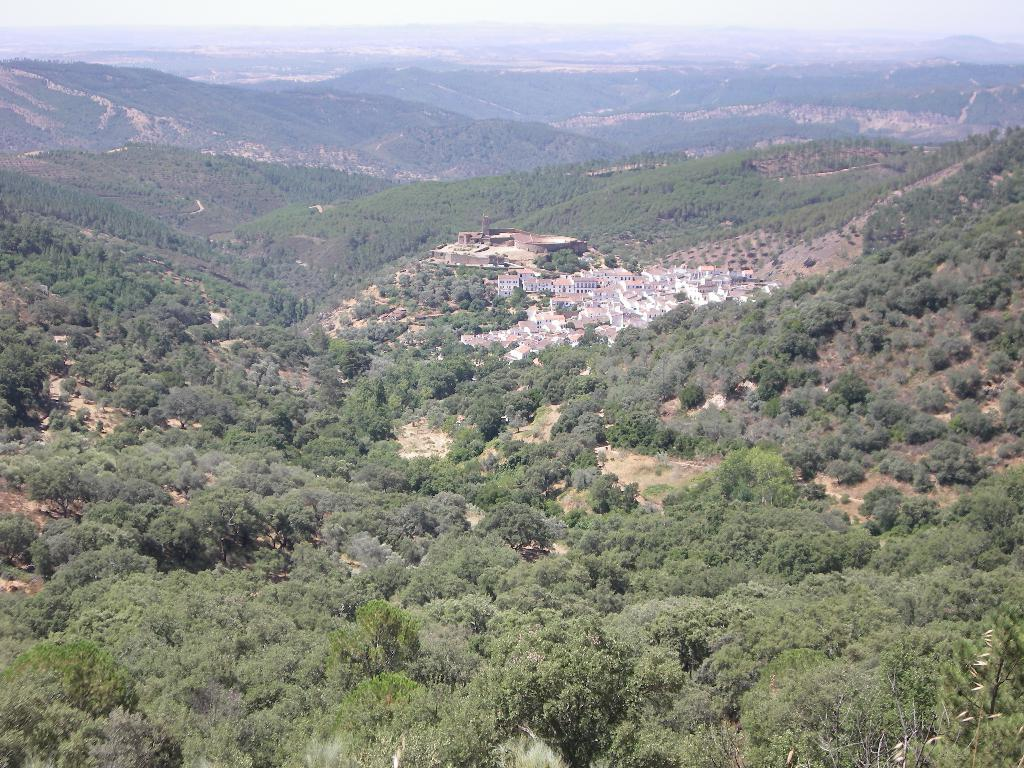What type of natural vegetation is present in the image? There are trees in the image. What type of man-made structures can be seen in the image? There are buildings in the image. What type of geographical feature is present in the image? There are hills in the image. What is visible in the background of the image? The sky is visible in the background of the image. Where is the silver throne located in the image? There is no silver throne present in the image. What type of industry is depicted in the image? There is no industry depicted in the image; it features trees, buildings, hills, and the sky. 